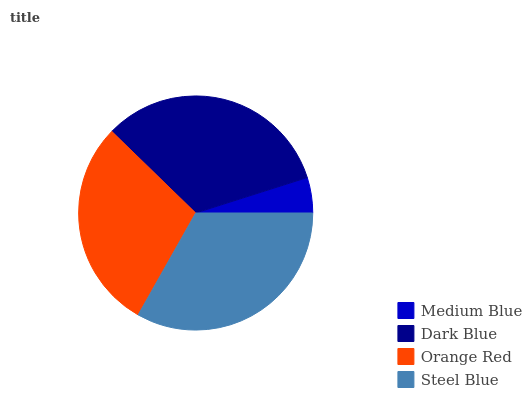Is Medium Blue the minimum?
Answer yes or no. Yes. Is Steel Blue the maximum?
Answer yes or no. Yes. Is Dark Blue the minimum?
Answer yes or no. No. Is Dark Blue the maximum?
Answer yes or no. No. Is Dark Blue greater than Medium Blue?
Answer yes or no. Yes. Is Medium Blue less than Dark Blue?
Answer yes or no. Yes. Is Medium Blue greater than Dark Blue?
Answer yes or no. No. Is Dark Blue less than Medium Blue?
Answer yes or no. No. Is Dark Blue the high median?
Answer yes or no. Yes. Is Orange Red the low median?
Answer yes or no. Yes. Is Medium Blue the high median?
Answer yes or no. No. Is Dark Blue the low median?
Answer yes or no. No. 